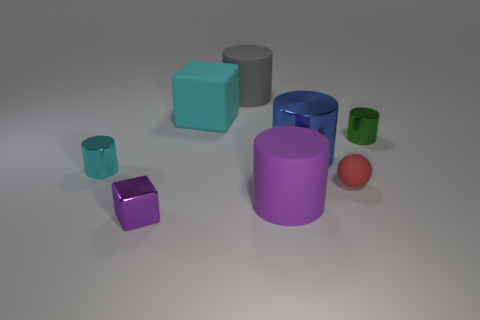Does the small object to the left of the purple cube have the same shape as the tiny red thing? no 